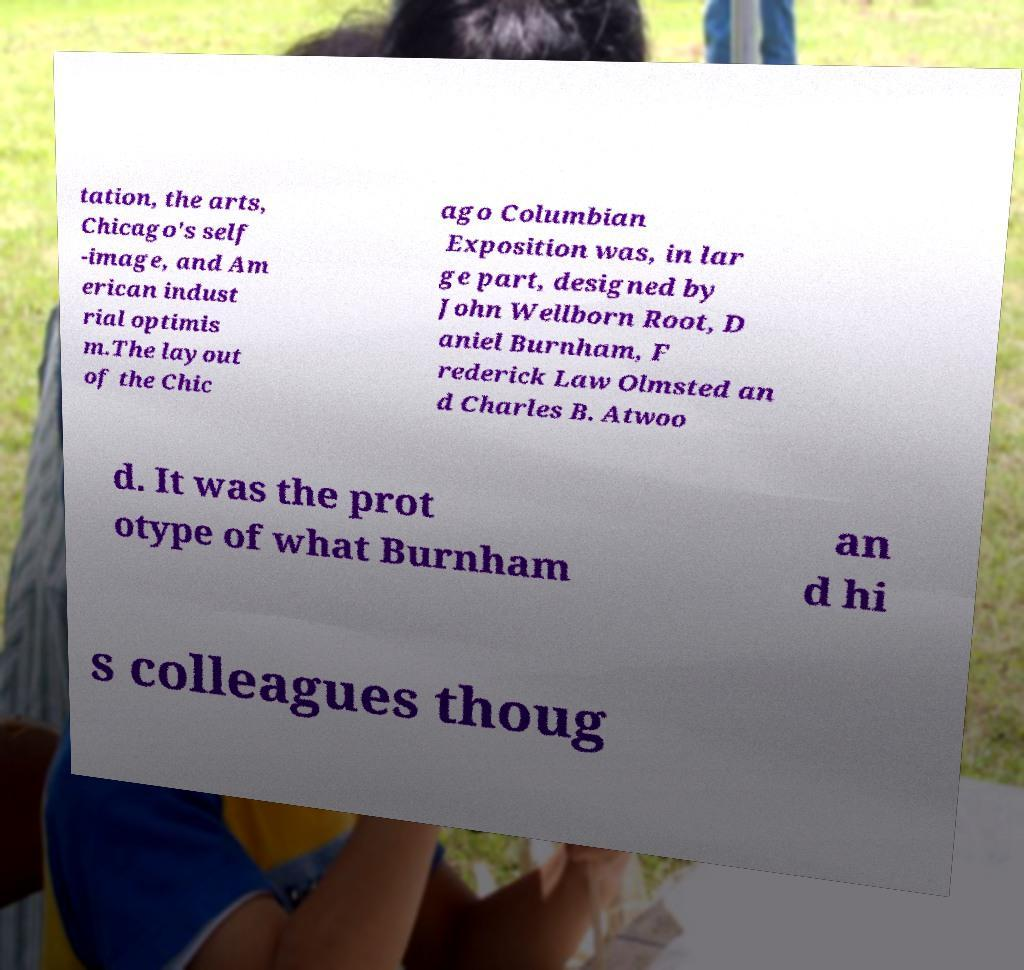Please identify and transcribe the text found in this image. tation, the arts, Chicago's self -image, and Am erican indust rial optimis m.The layout of the Chic ago Columbian Exposition was, in lar ge part, designed by John Wellborn Root, D aniel Burnham, F rederick Law Olmsted an d Charles B. Atwoo d. It was the prot otype of what Burnham an d hi s colleagues thoug 